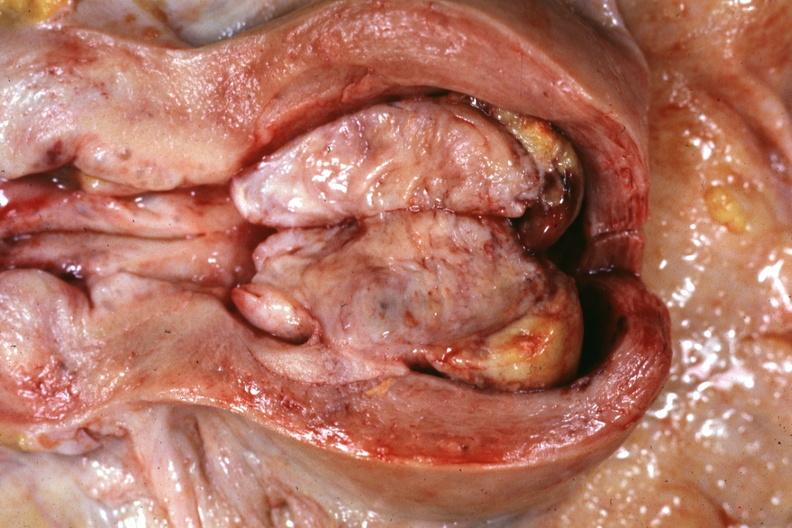what is present?
Answer the question using a single word or phrase. Mixed mesodermal tumor 